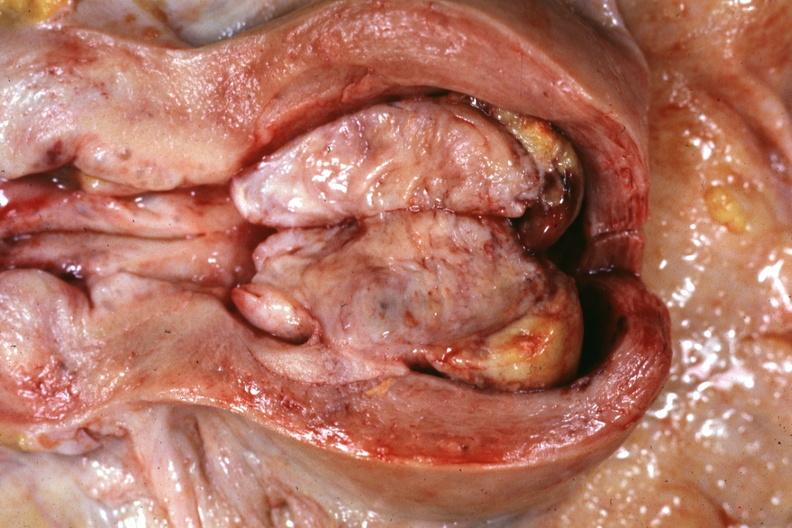what is present?
Answer the question using a single word or phrase. Mixed mesodermal tumor 